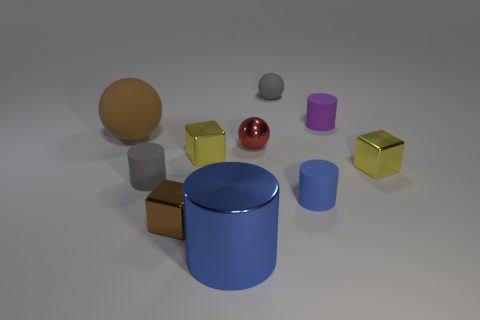How does the lighting in the image affect the appearance of the objects? The lighting from above casts soft shadows around the objects, enhancing their three-dimensional forms and complementing the colors and materials with a gentle contrast. 